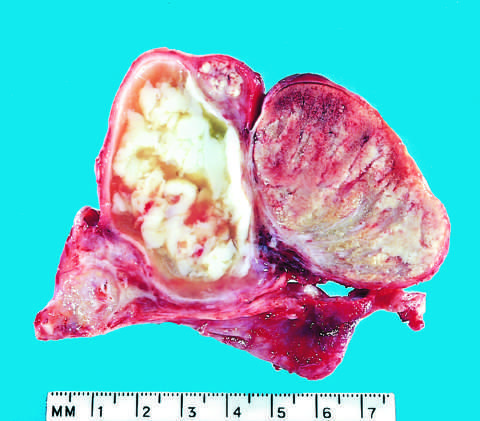s normal testis seen on the right?
Answer the question using a single word or phrase. Yes 